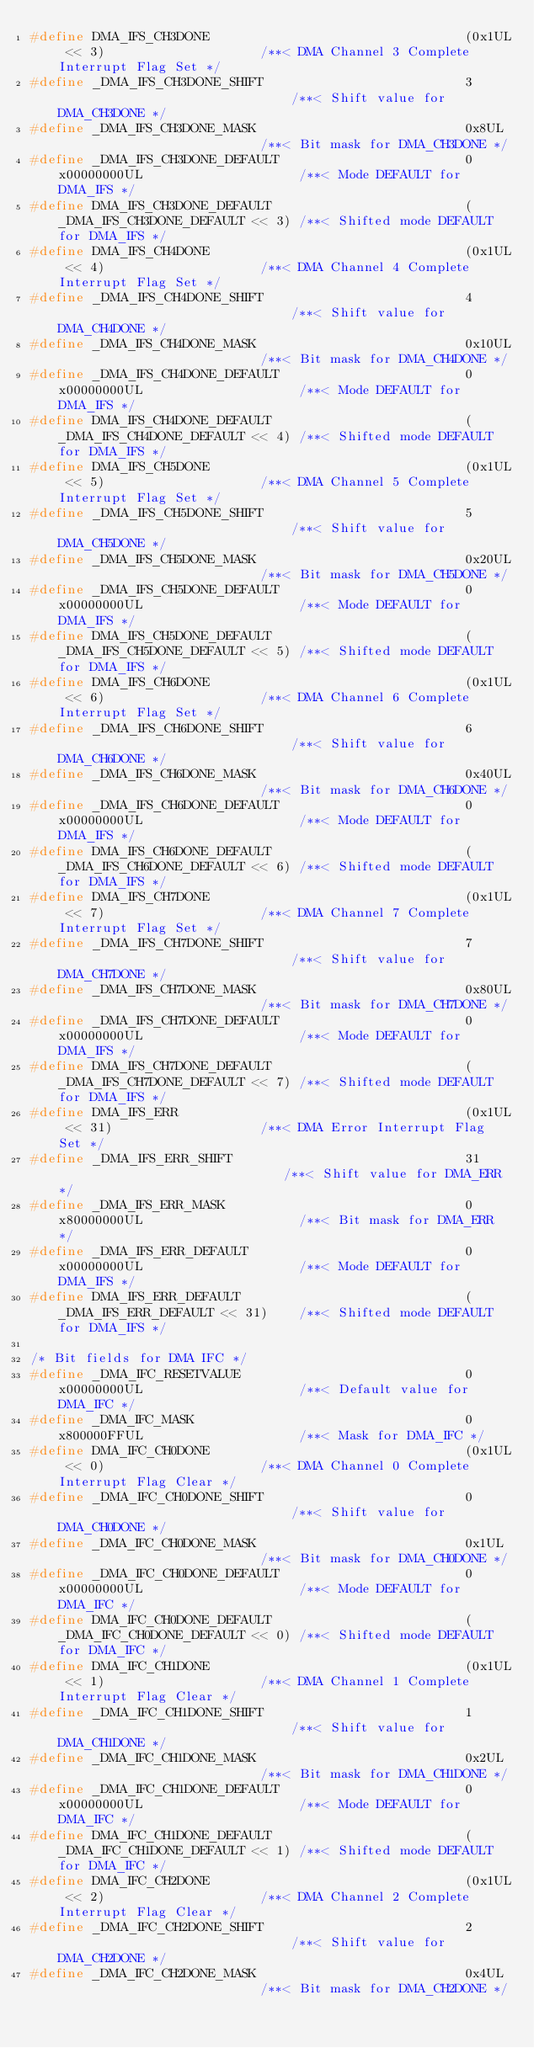Convert code to text. <code><loc_0><loc_0><loc_500><loc_500><_C_>#define DMA_IFS_CH3DONE                                 (0x1UL << 3)                    /**< DMA Channel 3 Complete Interrupt Flag Set */
#define _DMA_IFS_CH3DONE_SHIFT                          3                               /**< Shift value for DMA_CH3DONE */
#define _DMA_IFS_CH3DONE_MASK                           0x8UL                           /**< Bit mask for DMA_CH3DONE */
#define _DMA_IFS_CH3DONE_DEFAULT                        0x00000000UL                    /**< Mode DEFAULT for DMA_IFS */
#define DMA_IFS_CH3DONE_DEFAULT                         (_DMA_IFS_CH3DONE_DEFAULT << 3) /**< Shifted mode DEFAULT for DMA_IFS */
#define DMA_IFS_CH4DONE                                 (0x1UL << 4)                    /**< DMA Channel 4 Complete Interrupt Flag Set */
#define _DMA_IFS_CH4DONE_SHIFT                          4                               /**< Shift value for DMA_CH4DONE */
#define _DMA_IFS_CH4DONE_MASK                           0x10UL                          /**< Bit mask for DMA_CH4DONE */
#define _DMA_IFS_CH4DONE_DEFAULT                        0x00000000UL                    /**< Mode DEFAULT for DMA_IFS */
#define DMA_IFS_CH4DONE_DEFAULT                         (_DMA_IFS_CH4DONE_DEFAULT << 4) /**< Shifted mode DEFAULT for DMA_IFS */
#define DMA_IFS_CH5DONE                                 (0x1UL << 5)                    /**< DMA Channel 5 Complete Interrupt Flag Set */
#define _DMA_IFS_CH5DONE_SHIFT                          5                               /**< Shift value for DMA_CH5DONE */
#define _DMA_IFS_CH5DONE_MASK                           0x20UL                          /**< Bit mask for DMA_CH5DONE */
#define _DMA_IFS_CH5DONE_DEFAULT                        0x00000000UL                    /**< Mode DEFAULT for DMA_IFS */
#define DMA_IFS_CH5DONE_DEFAULT                         (_DMA_IFS_CH5DONE_DEFAULT << 5) /**< Shifted mode DEFAULT for DMA_IFS */
#define DMA_IFS_CH6DONE                                 (0x1UL << 6)                    /**< DMA Channel 6 Complete Interrupt Flag Set */
#define _DMA_IFS_CH6DONE_SHIFT                          6                               /**< Shift value for DMA_CH6DONE */
#define _DMA_IFS_CH6DONE_MASK                           0x40UL                          /**< Bit mask for DMA_CH6DONE */
#define _DMA_IFS_CH6DONE_DEFAULT                        0x00000000UL                    /**< Mode DEFAULT for DMA_IFS */
#define DMA_IFS_CH6DONE_DEFAULT                         (_DMA_IFS_CH6DONE_DEFAULT << 6) /**< Shifted mode DEFAULT for DMA_IFS */
#define DMA_IFS_CH7DONE                                 (0x1UL << 7)                    /**< DMA Channel 7 Complete Interrupt Flag Set */
#define _DMA_IFS_CH7DONE_SHIFT                          7                               /**< Shift value for DMA_CH7DONE */
#define _DMA_IFS_CH7DONE_MASK                           0x80UL                          /**< Bit mask for DMA_CH7DONE */
#define _DMA_IFS_CH7DONE_DEFAULT                        0x00000000UL                    /**< Mode DEFAULT for DMA_IFS */
#define DMA_IFS_CH7DONE_DEFAULT                         (_DMA_IFS_CH7DONE_DEFAULT << 7) /**< Shifted mode DEFAULT for DMA_IFS */
#define DMA_IFS_ERR                                     (0x1UL << 31)                   /**< DMA Error Interrupt Flag Set */
#define _DMA_IFS_ERR_SHIFT                              31                              /**< Shift value for DMA_ERR */
#define _DMA_IFS_ERR_MASK                               0x80000000UL                    /**< Bit mask for DMA_ERR */
#define _DMA_IFS_ERR_DEFAULT                            0x00000000UL                    /**< Mode DEFAULT for DMA_IFS */
#define DMA_IFS_ERR_DEFAULT                             (_DMA_IFS_ERR_DEFAULT << 31)    /**< Shifted mode DEFAULT for DMA_IFS */

/* Bit fields for DMA IFC */
#define _DMA_IFC_RESETVALUE                             0x00000000UL                    /**< Default value for DMA_IFC */
#define _DMA_IFC_MASK                                   0x800000FFUL                    /**< Mask for DMA_IFC */
#define DMA_IFC_CH0DONE                                 (0x1UL << 0)                    /**< DMA Channel 0 Complete Interrupt Flag Clear */
#define _DMA_IFC_CH0DONE_SHIFT                          0                               /**< Shift value for DMA_CH0DONE */
#define _DMA_IFC_CH0DONE_MASK                           0x1UL                           /**< Bit mask for DMA_CH0DONE */
#define _DMA_IFC_CH0DONE_DEFAULT                        0x00000000UL                    /**< Mode DEFAULT for DMA_IFC */
#define DMA_IFC_CH0DONE_DEFAULT                         (_DMA_IFC_CH0DONE_DEFAULT << 0) /**< Shifted mode DEFAULT for DMA_IFC */
#define DMA_IFC_CH1DONE                                 (0x1UL << 1)                    /**< DMA Channel 1 Complete Interrupt Flag Clear */
#define _DMA_IFC_CH1DONE_SHIFT                          1                               /**< Shift value for DMA_CH1DONE */
#define _DMA_IFC_CH1DONE_MASK                           0x2UL                           /**< Bit mask for DMA_CH1DONE */
#define _DMA_IFC_CH1DONE_DEFAULT                        0x00000000UL                    /**< Mode DEFAULT for DMA_IFC */
#define DMA_IFC_CH1DONE_DEFAULT                         (_DMA_IFC_CH1DONE_DEFAULT << 1) /**< Shifted mode DEFAULT for DMA_IFC */
#define DMA_IFC_CH2DONE                                 (0x1UL << 2)                    /**< DMA Channel 2 Complete Interrupt Flag Clear */
#define _DMA_IFC_CH2DONE_SHIFT                          2                               /**< Shift value for DMA_CH2DONE */
#define _DMA_IFC_CH2DONE_MASK                           0x4UL                           /**< Bit mask for DMA_CH2DONE */</code> 